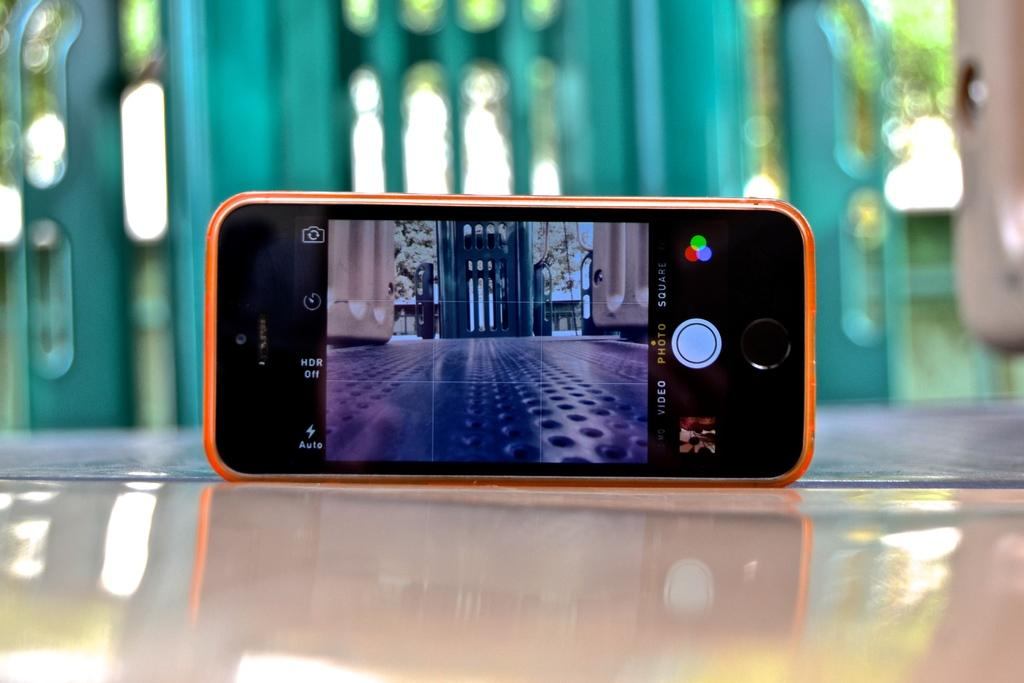<image>
Render a clear and concise summary of the photo. The selections for video and photo are visible on the screen of a cell phone. 